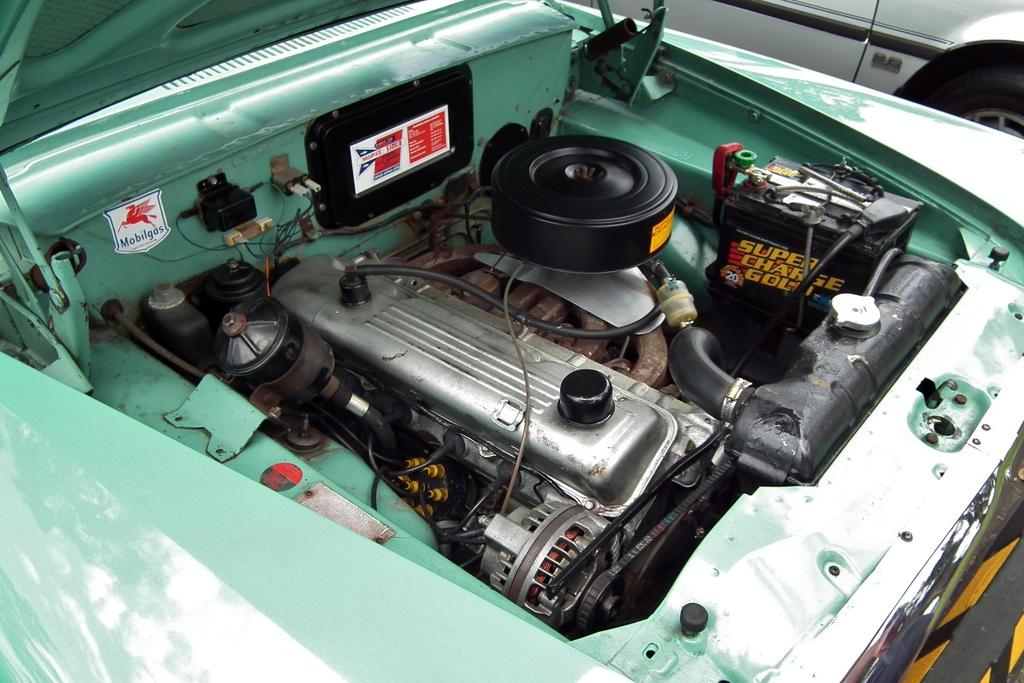How many cars are visible in the image? There are two cars in the image. What can be seen inside the cars? The image shows interior parts of the cars. Where might this image have been taken? The image may have been taken in a garage. What type of plant can be seen growing inside one of the cars? There is no plant visible inside either of the cars in the image. 